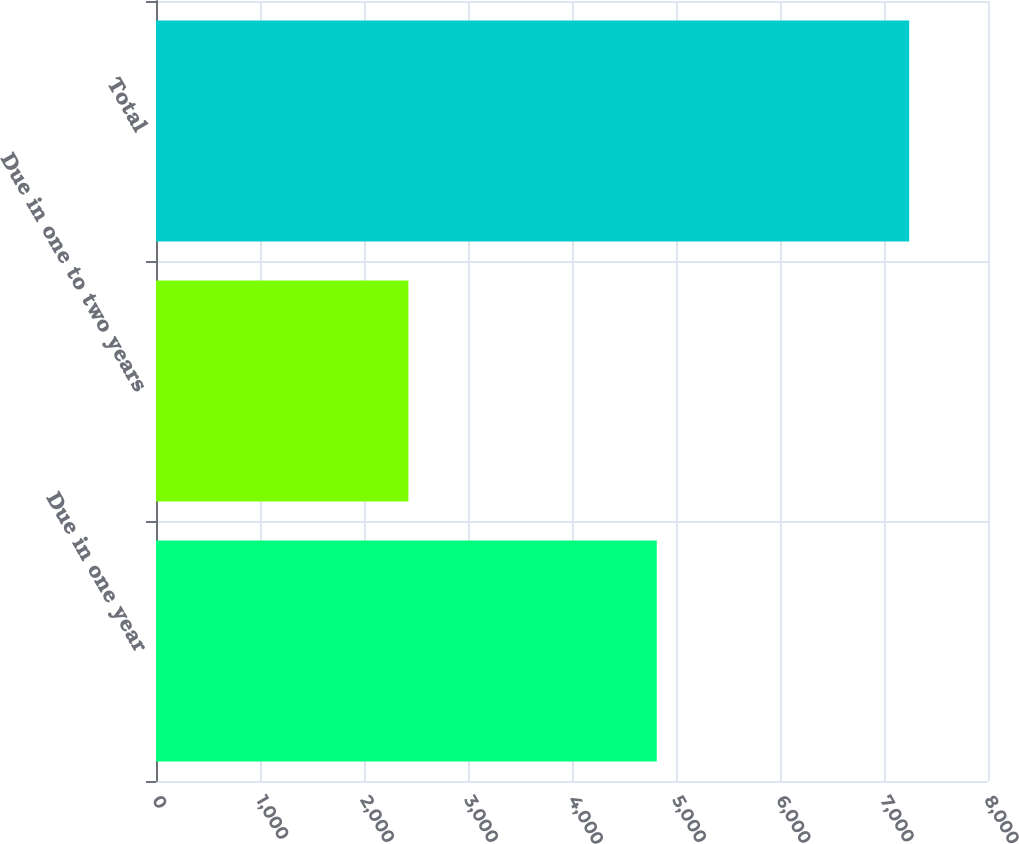Convert chart. <chart><loc_0><loc_0><loc_500><loc_500><bar_chart><fcel>Due in one year<fcel>Due in one to two years<fcel>Total<nl><fcel>4815<fcel>2427<fcel>7242<nl></chart> 